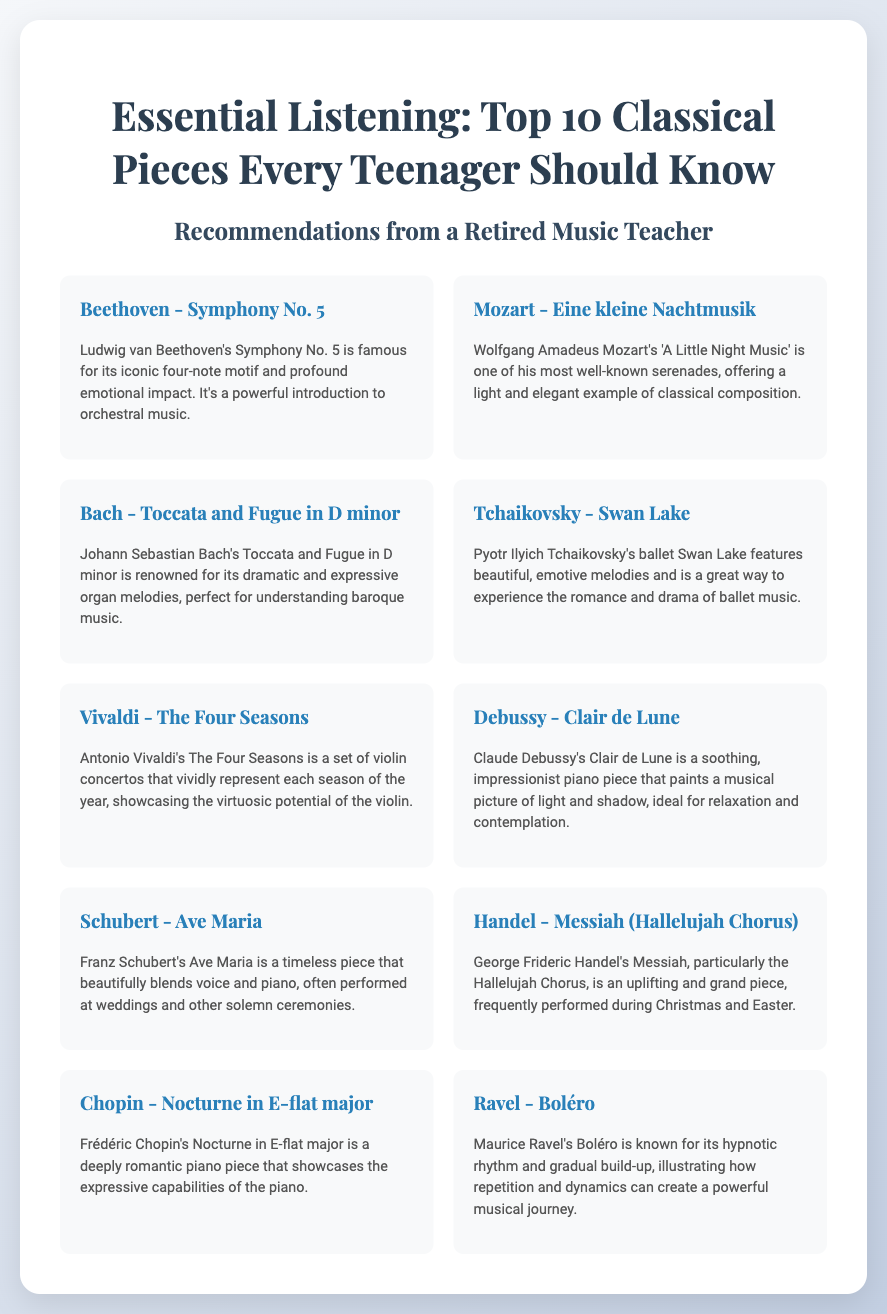What is the title of the poster? The title of the poster is found at the top, indicating the focus on classical music pieces.
Answer: Essential Listening: Top 10 Classical Pieces Every Teenager Should Know Who composed Symphony No. 5? The composer of Symphony No. 5 is mentioned in the piece description.
Answer: Ludwig van Beethoven What piece is known for its four-note motif? The description for the piece includes a detail about its distinctive feature.
Answer: Symphony No. 5 Which piece is associated with ballet music? The context of ballet music is specified in the description of one of the pieces.
Answer: Swan Lake How many pieces are listed in total? The total number of pieces is indicated by the title and content structure.
Answer: 10 Which composer is associated with the piece titled 'A Little Night Music'? The description specifies the composer related to that particular piece.
Answer: Wolfgang Amadeus Mozart What is the genre of 'Clair de Lune'? The type of music for 'Clair de Lune' is mentioned in its description.
Answer: Impressionist piano piece Which piece is often performed at weddings? The description for a specific piece suggests its common performance context.
Answer: Ave Maria What season does 'The Four Seasons' represent? The title itself suggests it relates to seasonal representations, covered in one of the pieces.
Answer: Each season of the year 